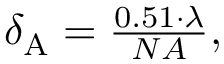Convert formula to latex. <formula><loc_0><loc_0><loc_500><loc_500>\begin{array} { r } { \delta _ { A } = \frac { 0 . 5 1 \cdot \lambda } { N A } , } \end{array}</formula> 